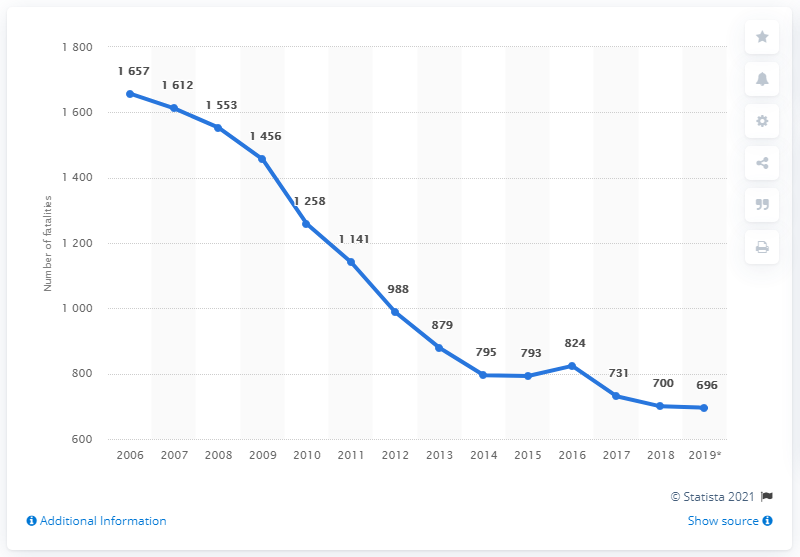In what year did the highest number of road fatalities occur?
 2006 